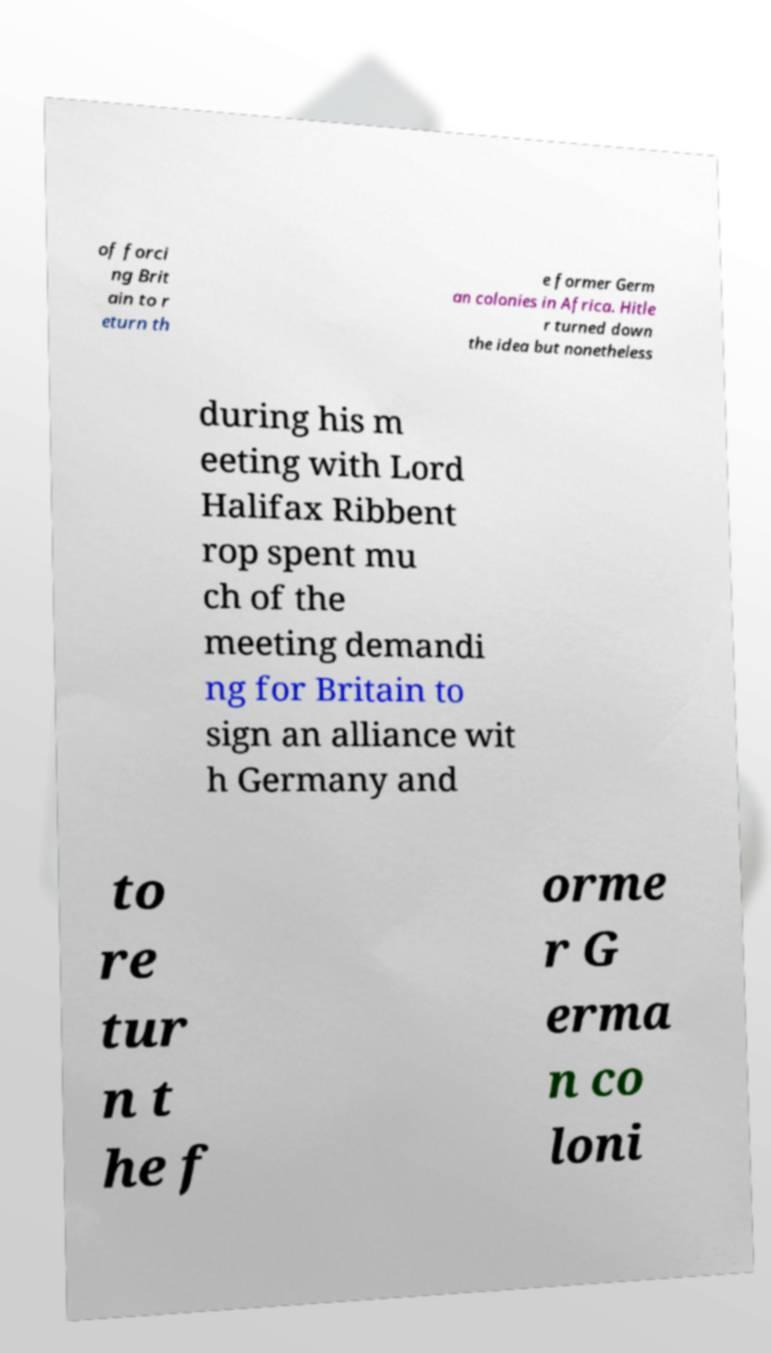There's text embedded in this image that I need extracted. Can you transcribe it verbatim? of forci ng Brit ain to r eturn th e former Germ an colonies in Africa. Hitle r turned down the idea but nonetheless during his m eeting with Lord Halifax Ribbent rop spent mu ch of the meeting demandi ng for Britain to sign an alliance wit h Germany and to re tur n t he f orme r G erma n co loni 